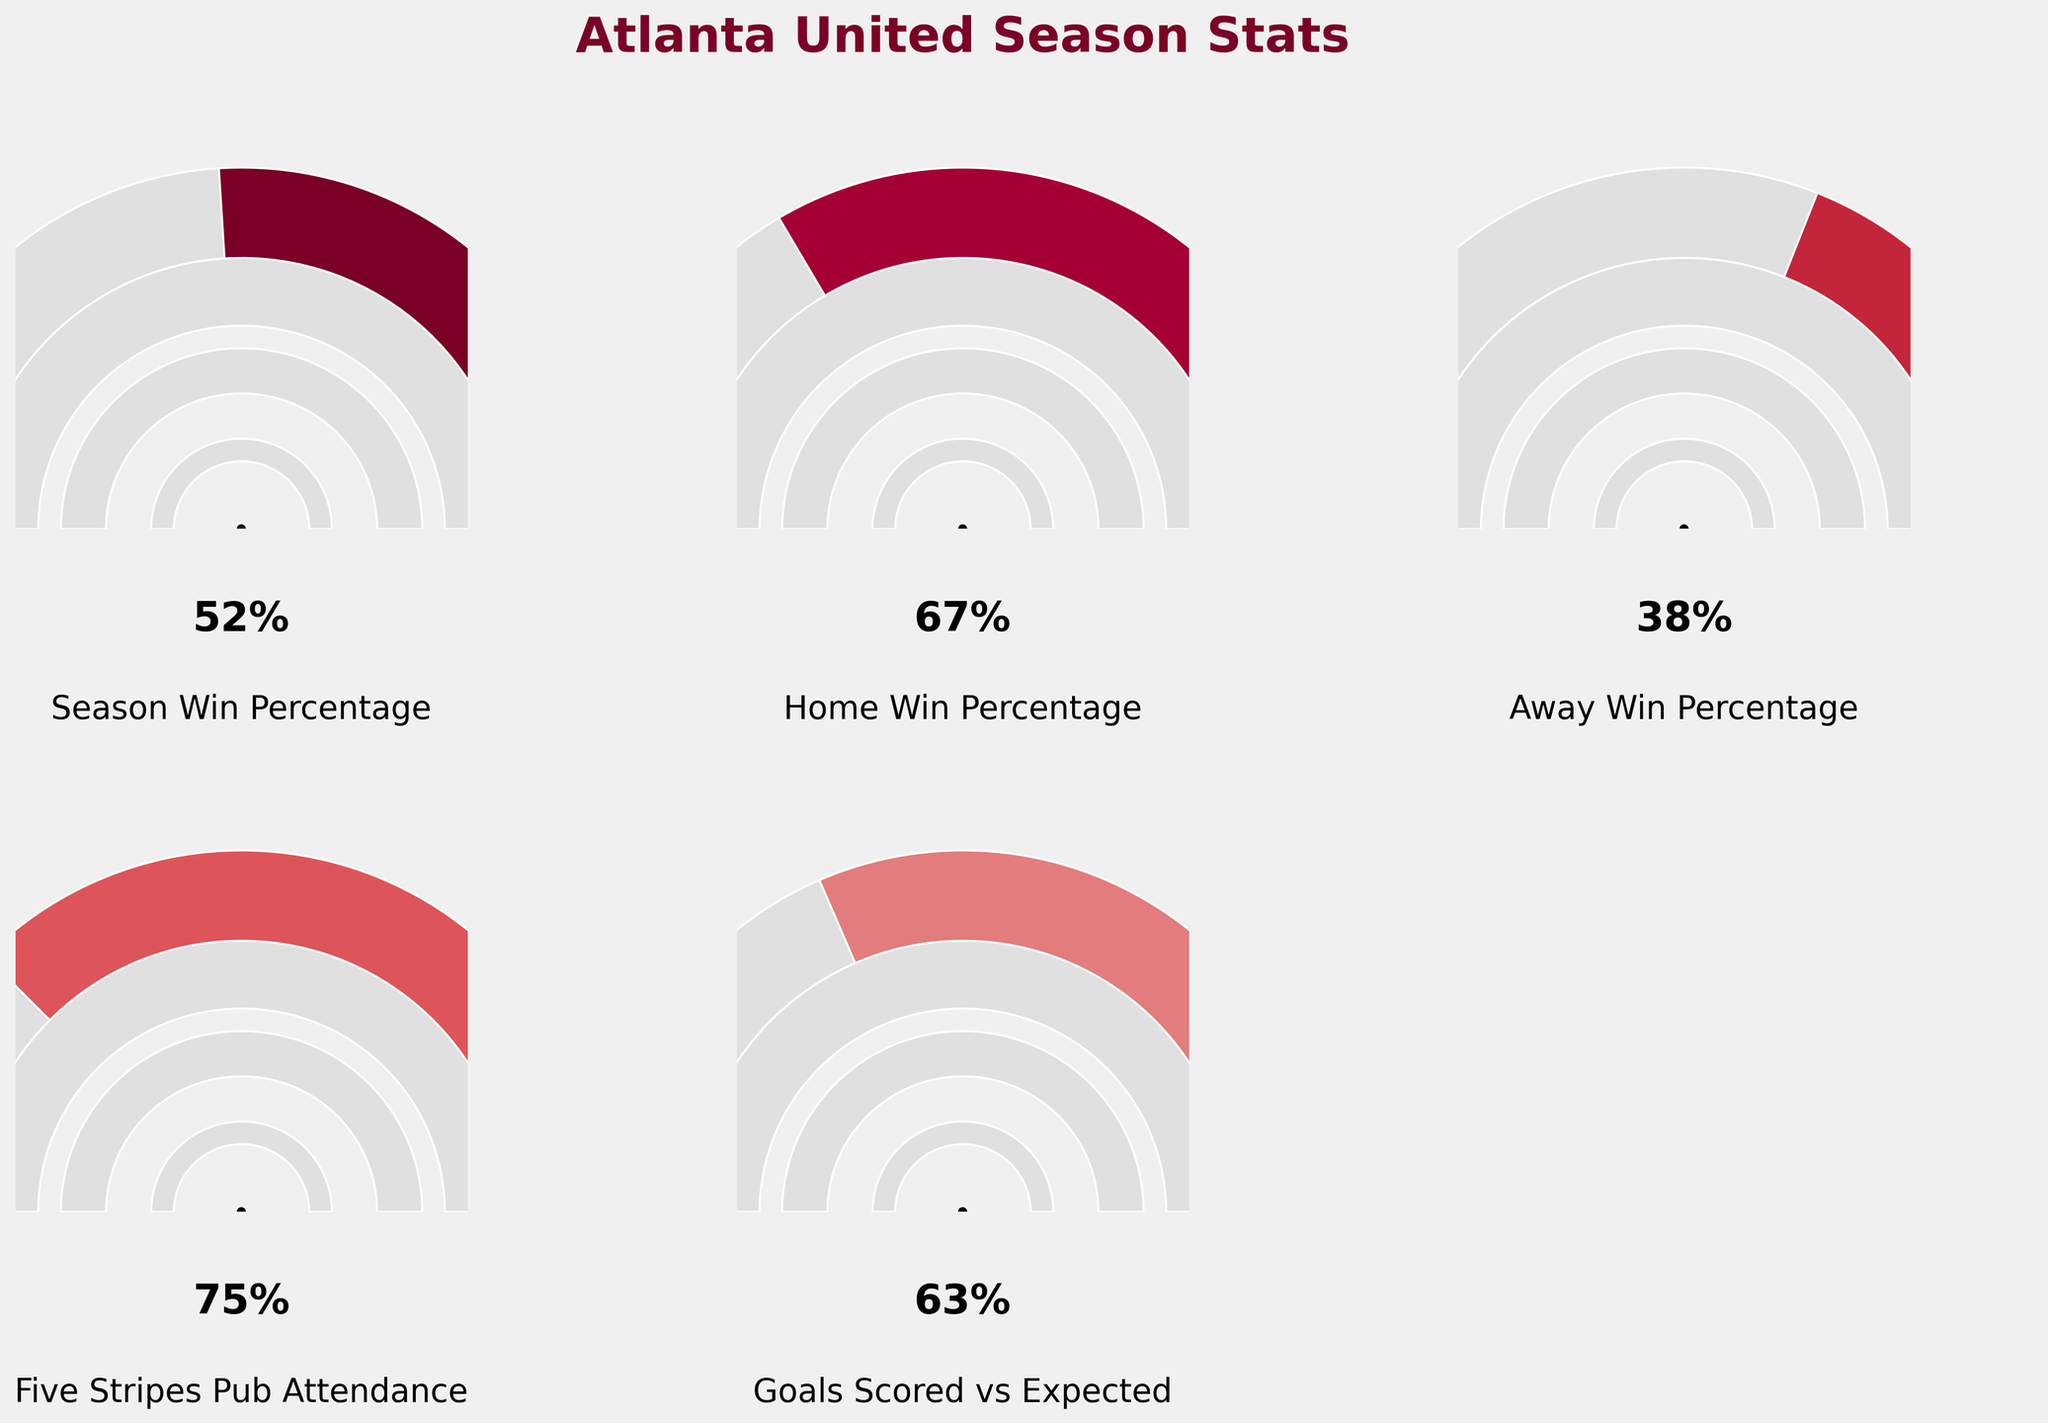What is the Atlanta United's Season Win Percentage according to the figure? Look at the gauge labeled "Season Win Percentage". The needle points to 0.52 or 52% on a scale from 0 to 1.
Answer: 52% What is the Home Win Percentage for Atlanta United? Refer to the gauge labeled "Home Win Percentage". The needle points to 0.67 or 67% on the scale.
Answer: 67% Which metric has the highest percentage value in the figure? Compare all the gauges. The "Five Stripes Pub Attendance" gauge shows the highest value of 0.75 or 75%.
Answer: Five Stripes Pub Attendance How does the Away Win Percentage compare to the Home Win Percentage? Look at both gauges. The Home Win Percentage is 0.67 (67%) and the Away Win Percentage is 0.38 (38%). The Home Win Percentage is higher.
Answer: Home Win Percentage is higher What is the difference between the Season Win Percentage and the Goals Scored vs Expected metric? Subtract the value of the "Season Win Percentage" (0.52) from the "Goals Scored vs Expected" (0.63). 0.63 - 0.52 = 0.11 or 11%.
Answer: 11% How much lower is the Away Win Percentage compared to the Season Win Percentage? Subtract the Away Win Percentage (0.38) from the Season Win Percentage (0.52). 0.52 - 0.38 = 0.14 or 14%.
Answer: 14% What percentage of attendees attend the Five Stripes Pub? Refer to the gauge labeled "Five Stripes Pub Attendance". The needle points to 0.75 or 75%.
Answer: 75% What is the combined percentage of the Season Win Percentage and Home Win Percentage? Add the Season Win Percentage (0.52) and the Home Win Percentage (0.67). 0.52 + 0.67 = 1.19 or 119%.
Answer: 119% Which value is closer to 50%, the Season Win Percentage or the Away Win Percentage? The Season Win Percentage is 0.52 (52%) and the Away Win Percentage is 0.38 (38%). The Season Win Percentage is closer to 50%.
Answer: Season Win Percentage If the Season Win Percentage were to increase by 10%, what would it be? Increase the current Season Win Percentage (0.52) by 0.10. 0.52 + 0.10 = 0.62 or 62%.
Answer: 62% 